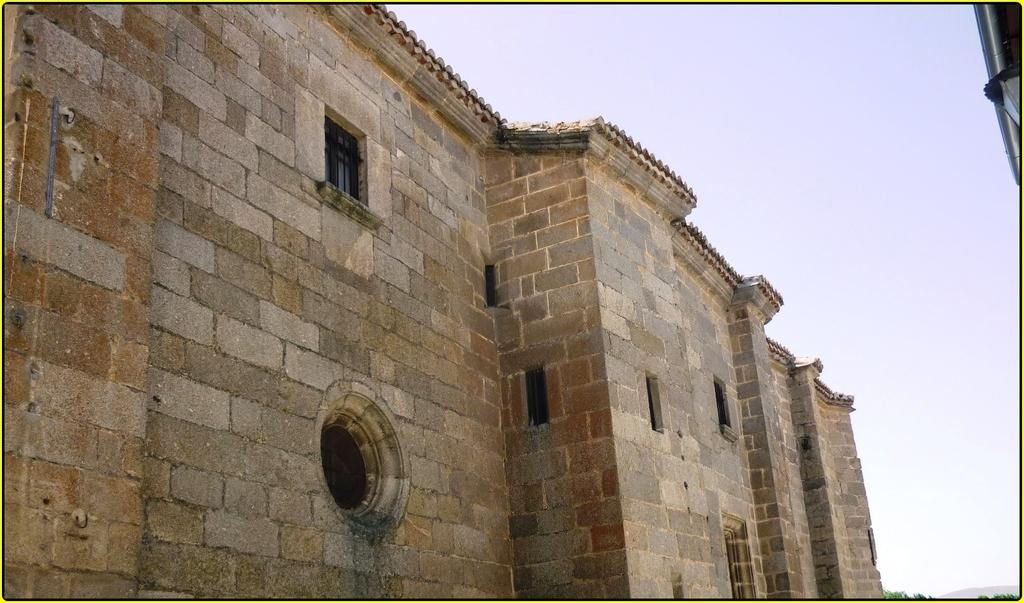What type of structure is present in the image? There is a building in the picture. What feature can be seen on the building? The building has windows. What type of vegetation is visible in the image? There are leaves visible in the image. What is visible in the background of the image? The sky is visible in the background of the image. Where is the boy sleeping in the image? There is no boy present in the image, and therefore no one is sleeping. 